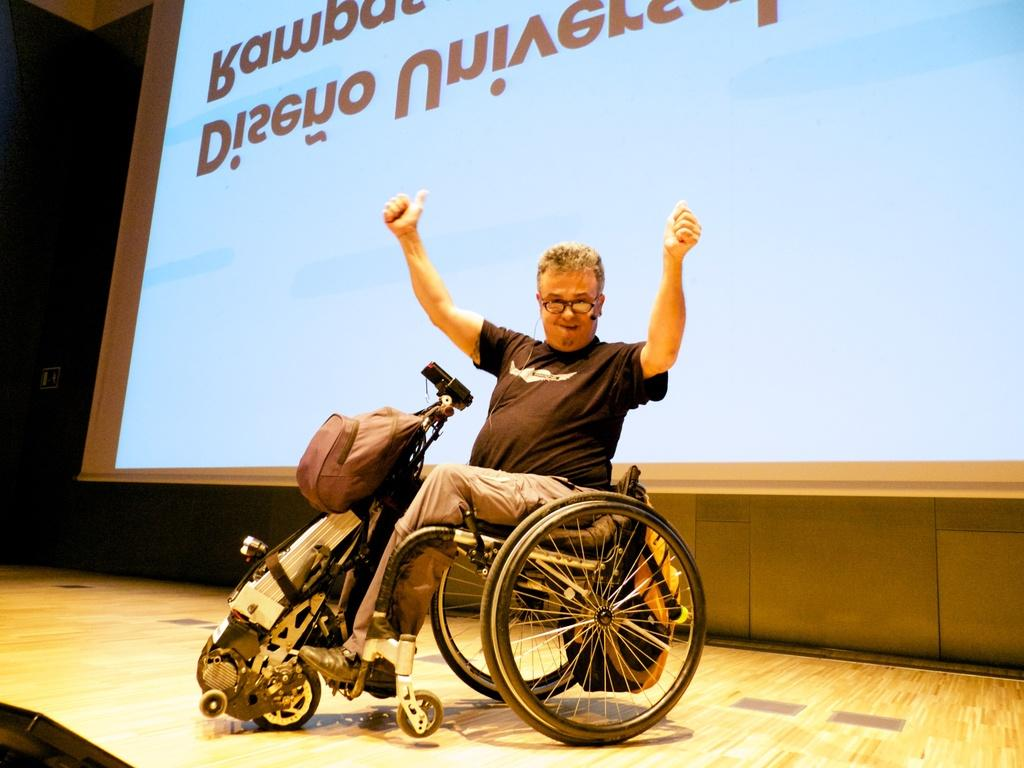Who is present in the image? There is a person in the image. What can be seen on the person's face? The person is wearing specs. What is the person sitting on in the image? The person is sitting on a wheelchair. What is attached to the wheelchair? The wheelchair has a bag on it. What can be seen in the background of the image? There is a screen in the background of the image. What flavor of cap is the person wearing in the image? The person is not wearing a cap in the image; they are wearing specs. How does the person blow bubbles in the image? There is no indication of the person blowing bubbles in the image. 